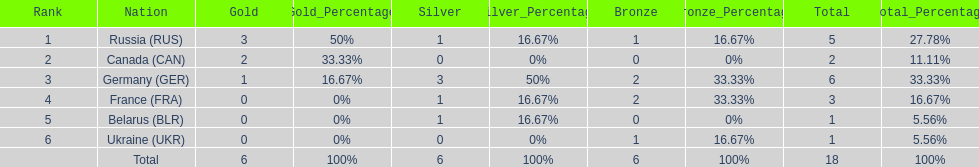What country only received gold medals in the 1994 winter olympics biathlon? Canada (CAN). 